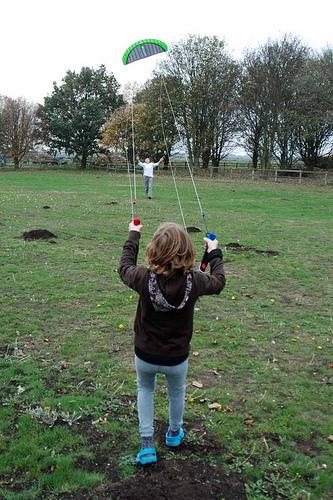Are the people having fun?
Quick response, please. Yes. How many hands is the child using?
Quick response, please. 2. Does a gopher live nearby?
Answer briefly. Yes. 